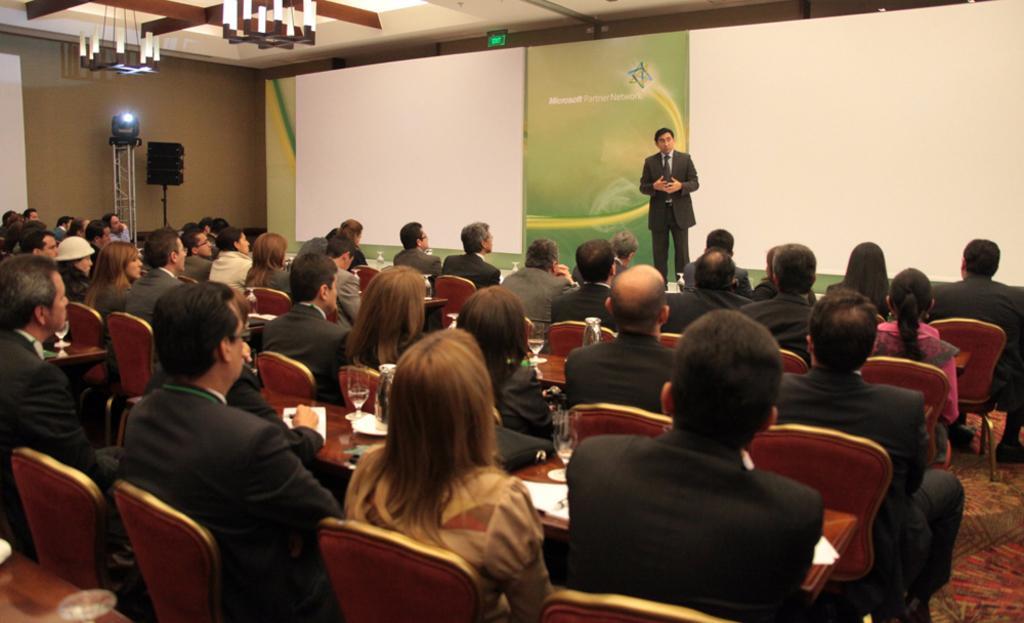Please provide a concise description of this image. This picture is clicked in the conference hall. Here, we see people sitting on the chairs. In front of them, we see tables on which papers and glasses containing water are placed. The man in white shirt and black blazer is standing on the stage. He is trying to talk something. Behind him, we see a green board and projector screens. On the left side, we see a speaker box and a stand on which light is placed. 